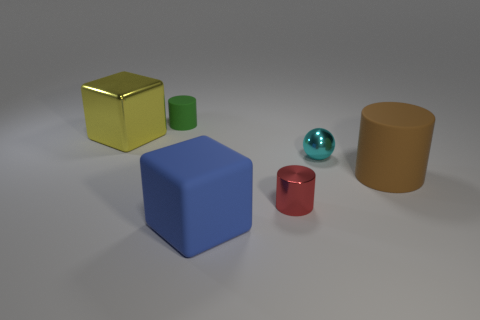Subtract all red cylinders. How many cylinders are left? 2 Add 3 small blue rubber things. How many objects exist? 9 Subtract all blocks. How many objects are left? 4 Subtract 2 cylinders. How many cylinders are left? 1 Add 2 large cylinders. How many large cylinders exist? 3 Subtract 0 gray blocks. How many objects are left? 6 Subtract all blue cubes. Subtract all green cylinders. How many cubes are left? 1 Subtract all small gray matte blocks. Subtract all big blocks. How many objects are left? 4 Add 2 tiny rubber cylinders. How many tiny rubber cylinders are left? 3 